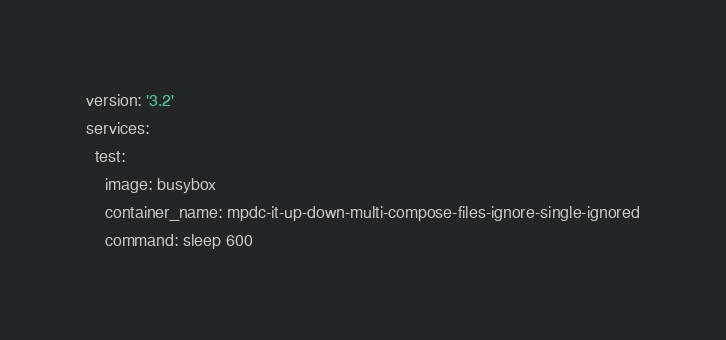<code> <loc_0><loc_0><loc_500><loc_500><_YAML_>version: '3.2'
services:
  test:
    image: busybox
    container_name: mpdc-it-up-down-multi-compose-files-ignore-single-ignored
    command: sleep 600
</code> 